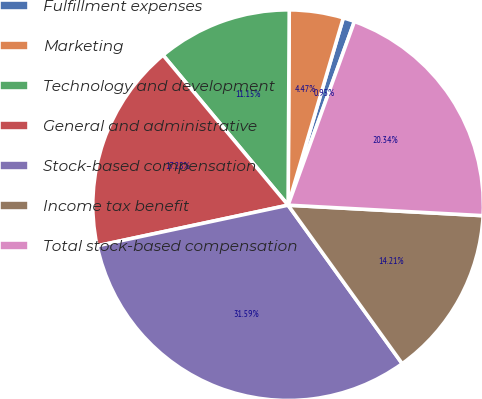<chart> <loc_0><loc_0><loc_500><loc_500><pie_chart><fcel>Fulfillment expenses<fcel>Marketing<fcel>Technology and development<fcel>General and administrative<fcel>Stock-based compensation<fcel>Income tax benefit<fcel>Total stock-based compensation<nl><fcel>0.95%<fcel>4.47%<fcel>11.15%<fcel>17.28%<fcel>31.59%<fcel>14.21%<fcel>20.34%<nl></chart> 